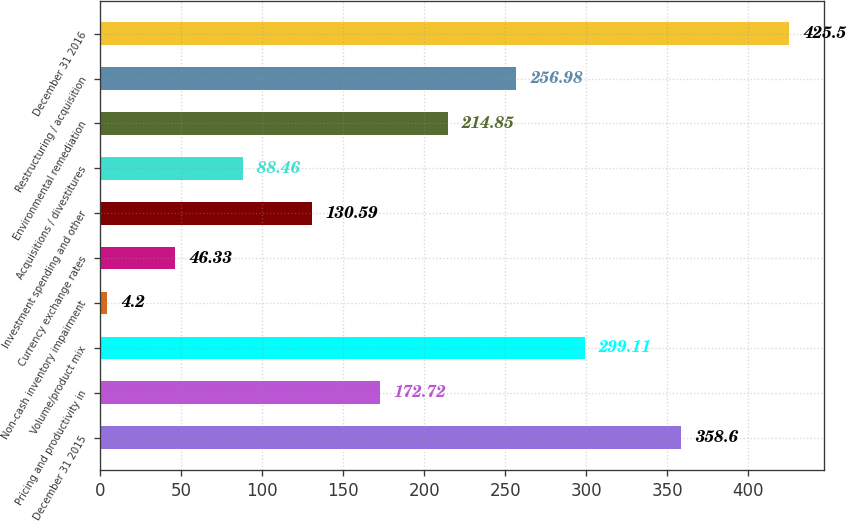Convert chart to OTSL. <chart><loc_0><loc_0><loc_500><loc_500><bar_chart><fcel>December 31 2015<fcel>Pricing and productivity in<fcel>Volume/product mix<fcel>Non-cash inventory impairment<fcel>Currency exchange rates<fcel>Investment spending and other<fcel>Acquisitions / divestitures<fcel>Environmental remediation<fcel>Restructuring / acquisition<fcel>December 31 2016<nl><fcel>358.6<fcel>172.72<fcel>299.11<fcel>4.2<fcel>46.33<fcel>130.59<fcel>88.46<fcel>214.85<fcel>256.98<fcel>425.5<nl></chart> 